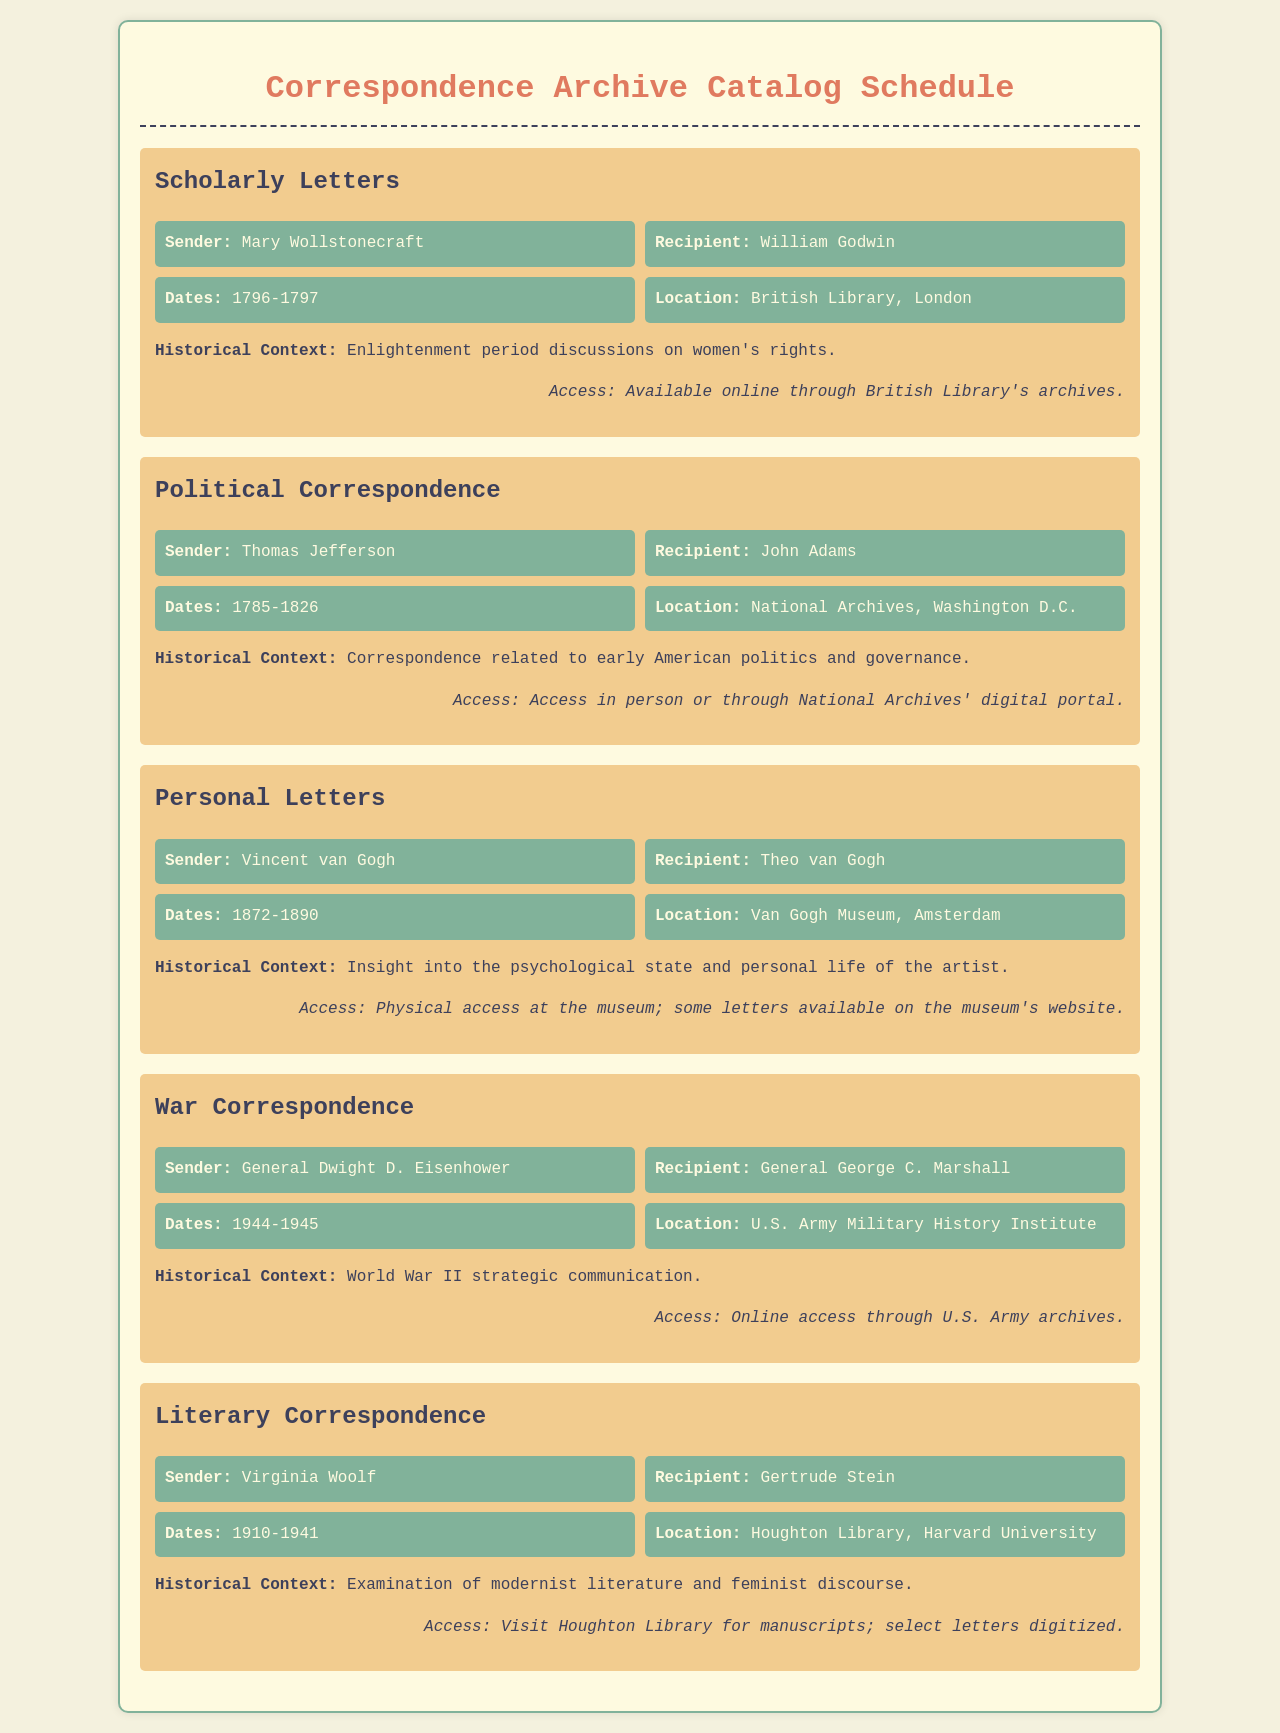What period do Mary Wollstonecraft's letters span? The document states that Mary Wollstonecraft's letters were written between 1796 and 1797.
Answer: 1796-1797 Who is the sender of the literary correspondence? The document specifies that the sender of the literary correspondence is Virginia Woolf.
Answer: Virginia Woolf What is the historical context of the war correspondence? The document explains that the war correspondence relates to World War II strategic communication.
Answer: World War II strategic communication Where can you access the personal letters of Vincent van Gogh? The document indicates that the personal letters are accessible at the Van Gogh Museum, Amsterdam.
Answer: Van Gogh Museum, Amsterdam Which archive contains the letters of Thomas Jefferson? According to the document, the letters of Thomas Jefferson are located in the National Archives, Washington D.C.
Answer: National Archives, Washington D.C How long did the correspondence between Thomas Jefferson and John Adams occur? The document mentions that their correspondence spanned from 1785 to 1826.
Answer: 1785-1826 What type of correspondence does General Dwight D. Eisenhower's letters belong to? The document classifies General Dwight D. Eisenhower's letters as war correspondence.
Answer: War Correspondence When are the letters of Virginia Woolf addressed to Gertrude Stein? The document notes that the letters to Gertrude Stein date from 1910 to 1941.
Answer: 1910-1941 How can one access Mary Wollstonecraft's letters? The document states that Mary Wollstonecraft's letters are available online through the British Library's archives.
Answer: Available online through British Library's archives 